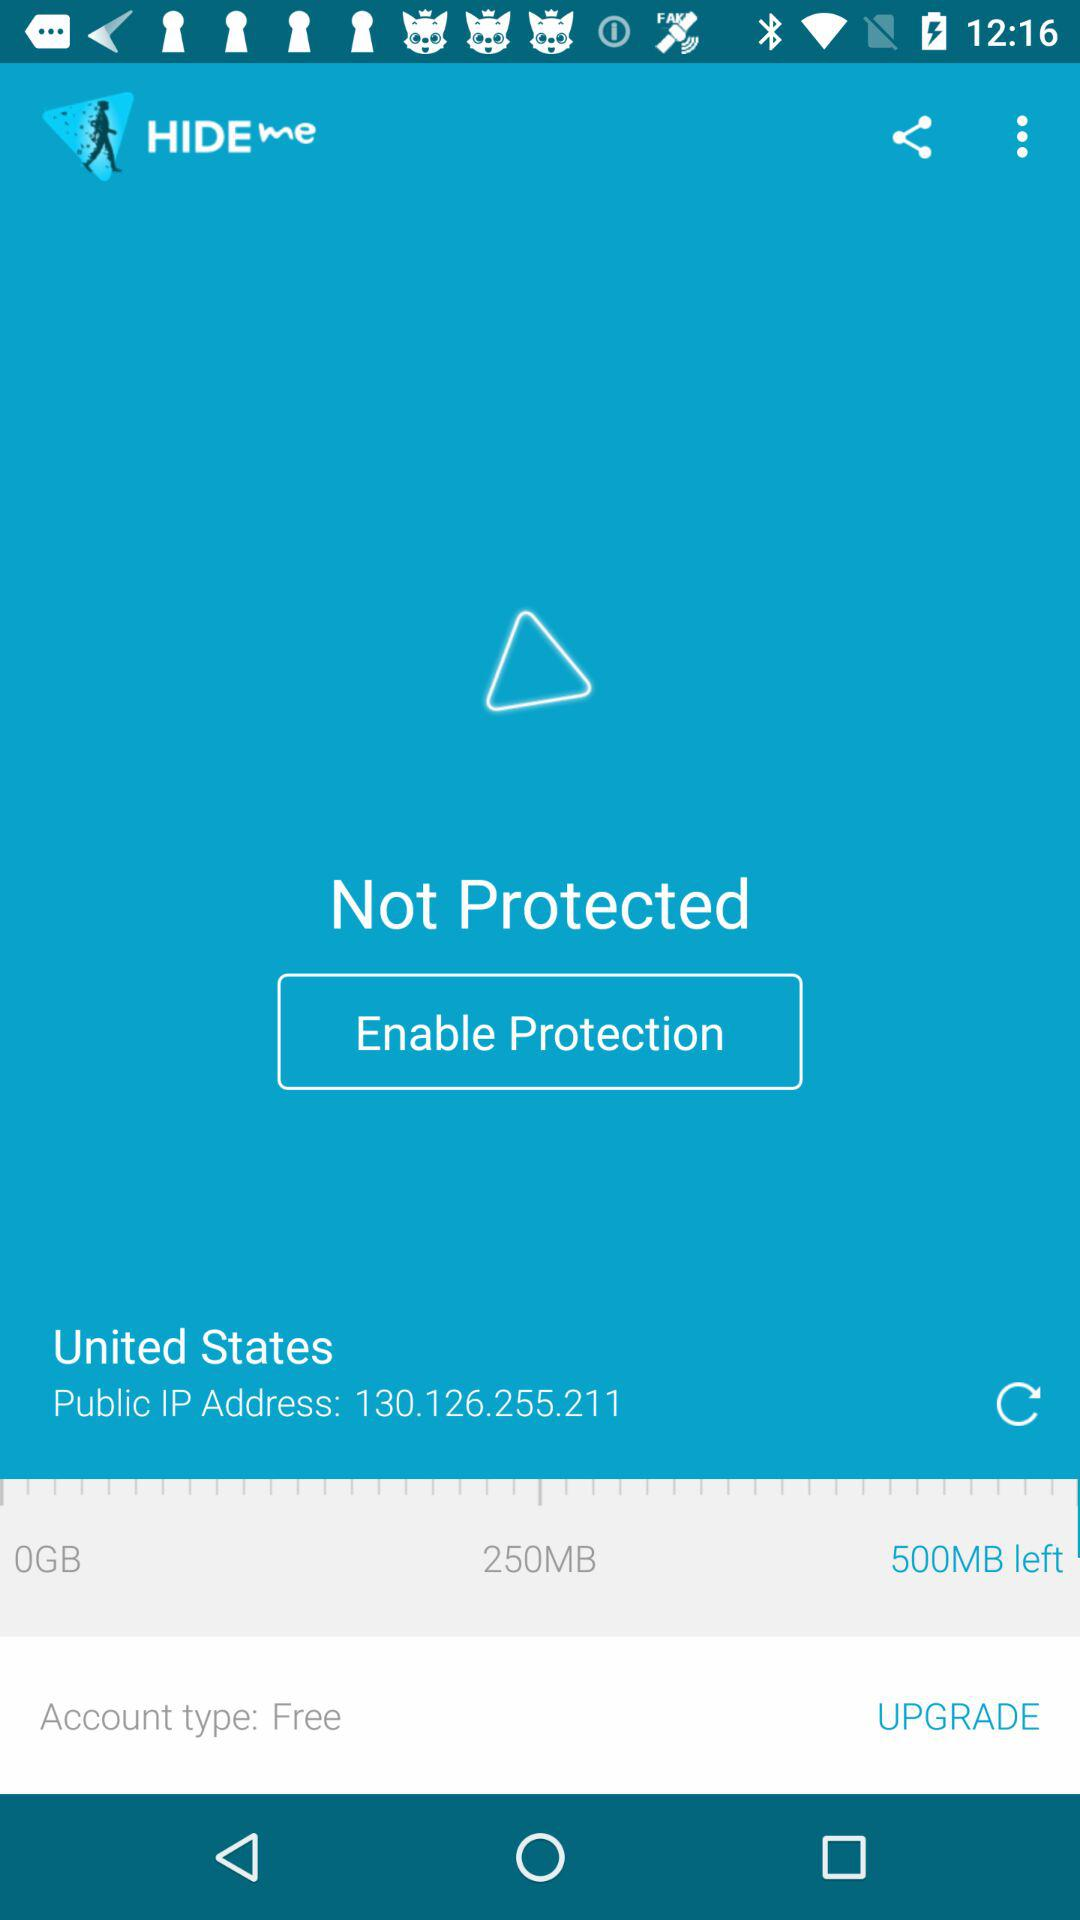What is the public IP address? The public IP address is 130.126.255.211. 